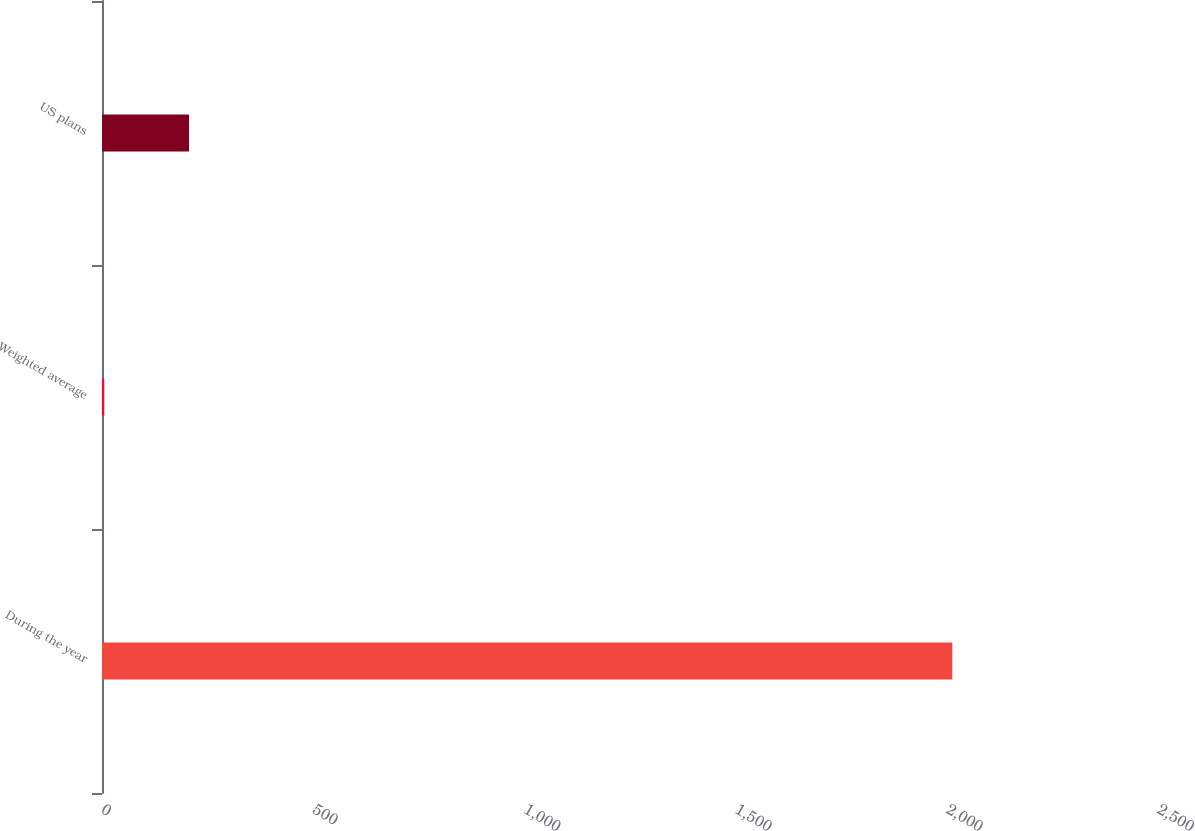Convert chart. <chart><loc_0><loc_0><loc_500><loc_500><bar_chart><fcel>During the year<fcel>Weighted average<fcel>US plans<nl><fcel>2013<fcel>5.24<fcel>206.02<nl></chart> 